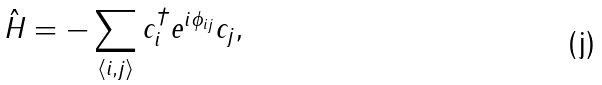<formula> <loc_0><loc_0><loc_500><loc_500>\hat { H } = - \sum _ { \langle i , j \rangle } c _ { i } ^ { \dagger } e ^ { i \phi _ { i j } } c _ { j } ,</formula> 